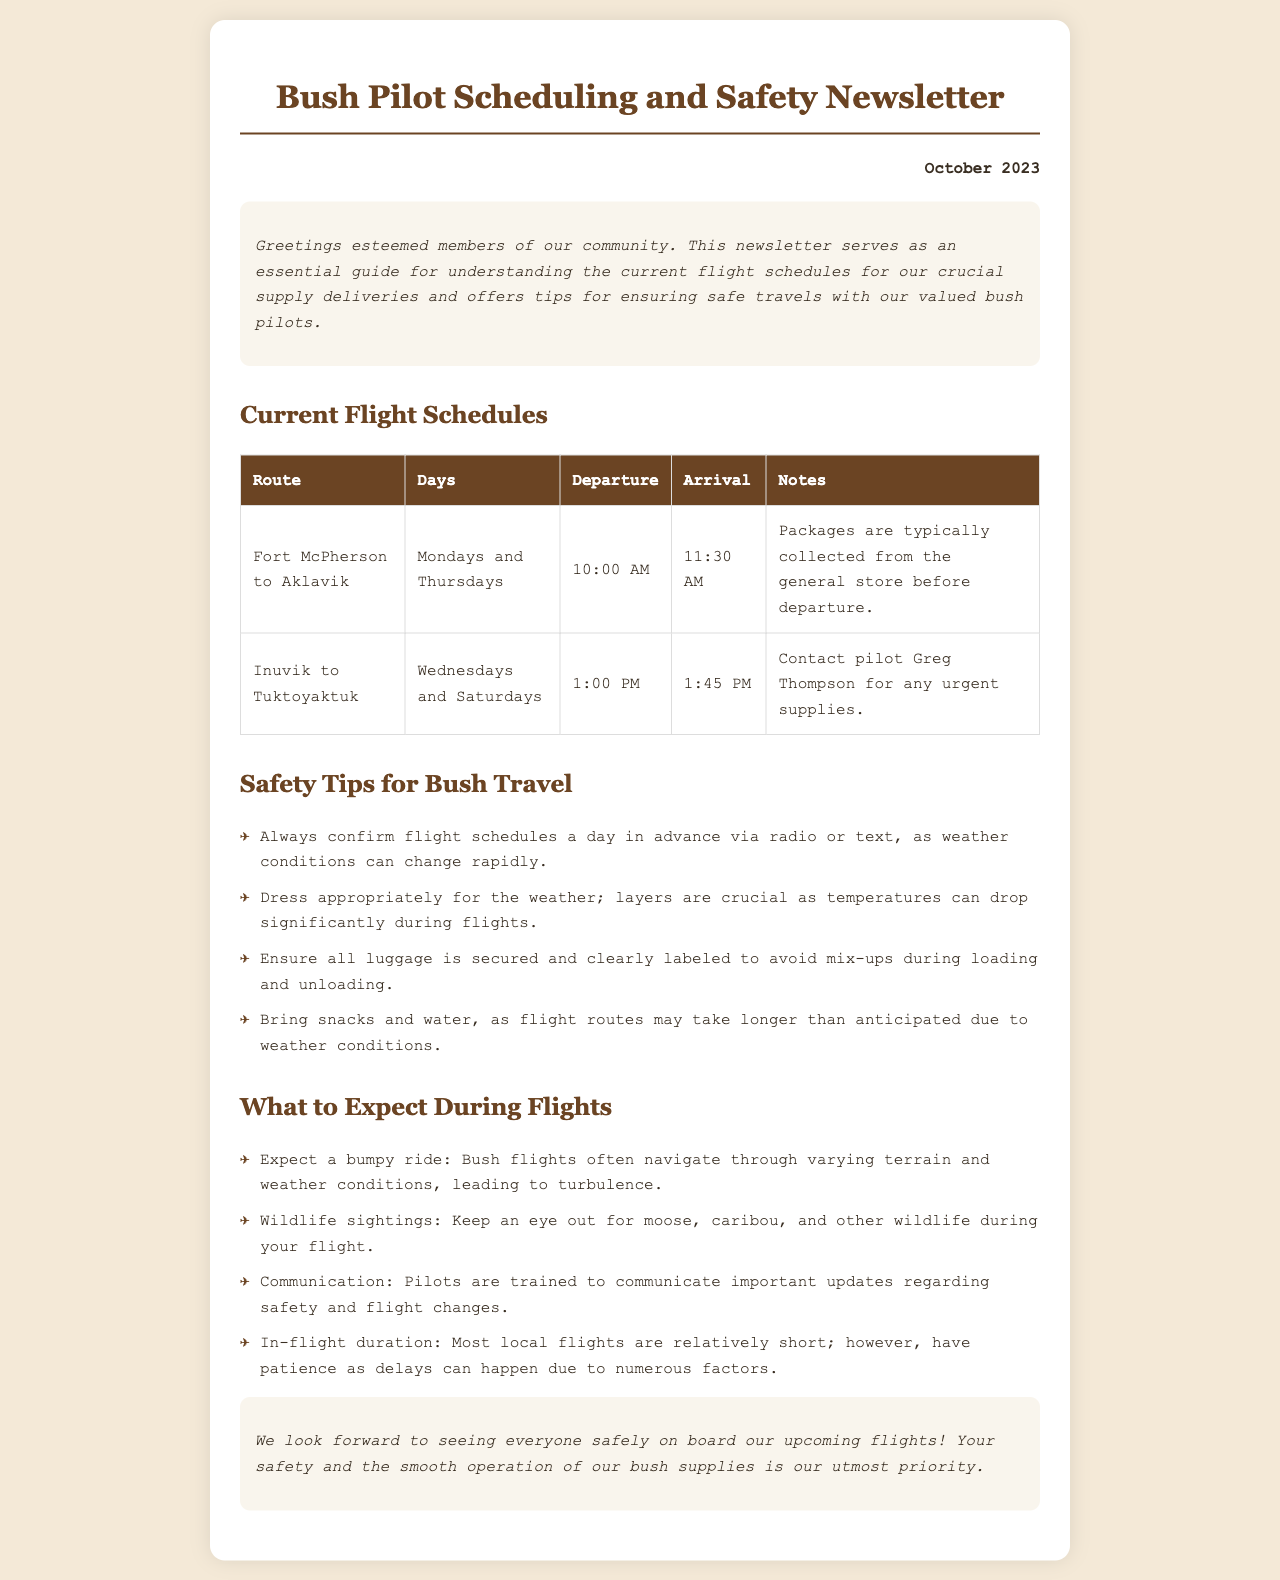What are the flight days from Fort McPherson to Aklavik? The document states that flights on this route operate on Mondays and Thursdays.
Answer: Mondays and Thursdays Who should be contacted for urgent supplies from Inuvik to Tuktoyaktuk? The newsletter indicates that pilot Greg Thompson should be contacted for any urgent supplies.
Answer: Greg Thompson What time does the flight from Inuvik to Tuktoyaktuk depart? According to the schedule, the departure time for this flight is 1:00 PM.
Answer: 1:00 PM What is one of the safety tips provided for bush travel? The document mentions the importance of confirming flight schedules a day in advance due to changing weather conditions.
Answer: Confirm flight schedules What can passengers expect during flights regarding wildlife? The document highlights that passengers should expect to see moose and caribou during flights.
Answer: Wildlife sightings How often do flights occur from Fort McPherson to Aklavik? The newsletter lists that flights occur twice a week for this route.
Answer: Twice a week What is the in-flight duration characteristic mentioned? The newsletter states that most local flights are relatively short, though delays can happen.
Answer: Relatively short What is the title of the newsletter? The document begins with the title clearly stating it as "Bush Pilot Scheduling and Safety Newsletter."
Answer: Bush Pilot Scheduling and Safety Newsletter What should passengers bring for comfort during the flight? The document advises bringing snacks and water in case flight durations are longer than expected.
Answer: Snacks and water 